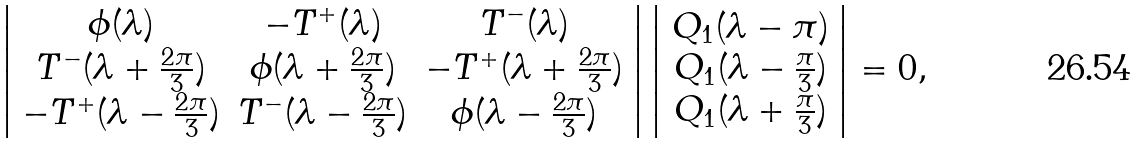<formula> <loc_0><loc_0><loc_500><loc_500>\left | \begin{array} { c c c } \phi ( \lambda ) & - T ^ { + } ( \lambda ) & T ^ { - } ( \lambda ) \\ T ^ { - } ( \lambda + \frac { 2 \pi } { 3 } ) & \phi ( \lambda + \frac { 2 \pi } { 3 } ) & - T ^ { + } ( \lambda + \frac { 2 \pi } { 3 } ) \\ - T ^ { + } ( \lambda - \frac { 2 \pi } { 3 } ) & T ^ { - } ( \lambda - \frac { 2 \pi } { 3 } ) & \phi ( \lambda - \frac { 2 \pi } { 3 } ) \end{array} \right | \left | \begin{array} { c } Q _ { 1 } ( \lambda - \pi ) \\ Q _ { 1 } ( \lambda - \frac { \pi } { 3 } ) \\ Q _ { 1 } ( \lambda + \frac { \pi } { 3 } ) \end{array} \right | = 0 ,</formula> 